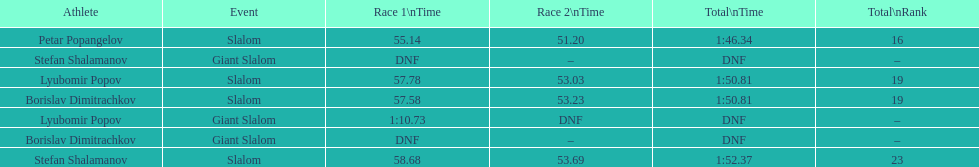Which athlete had a race time above 1:00? Lyubomir Popov. 